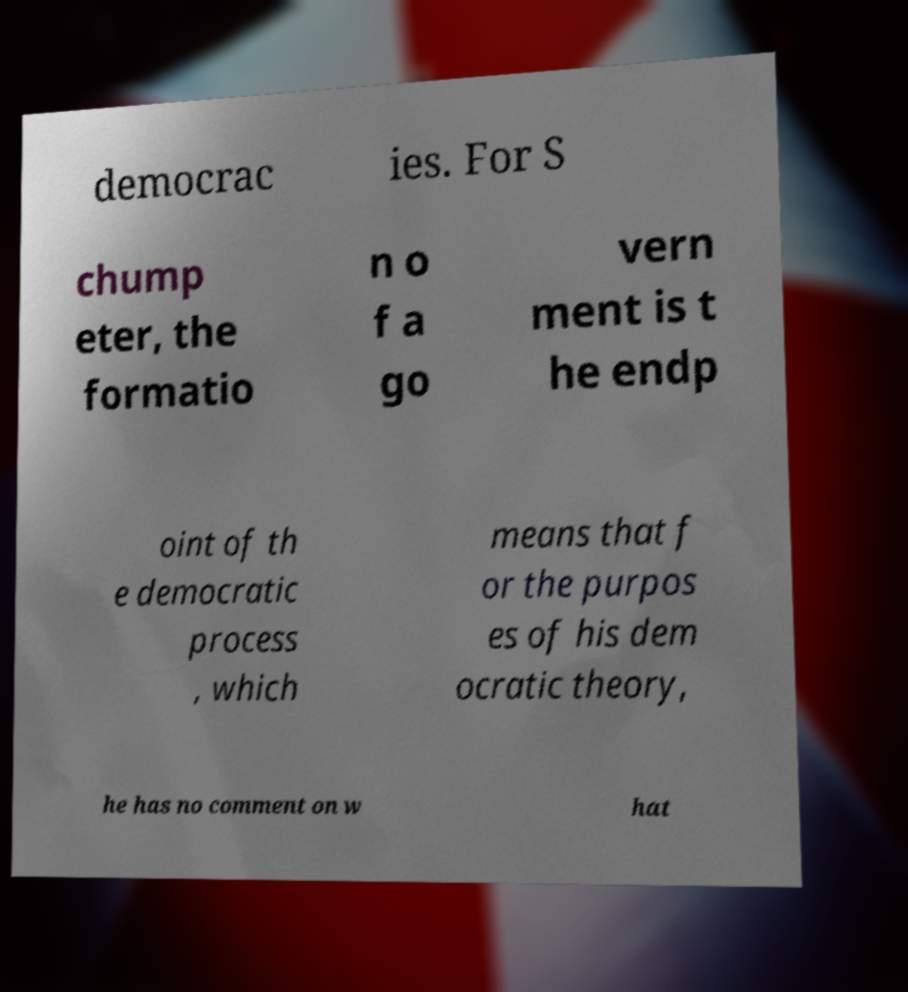I need the written content from this picture converted into text. Can you do that? democrac ies. For S chump eter, the formatio n o f a go vern ment is t he endp oint of th e democratic process , which means that f or the purpos es of his dem ocratic theory, he has no comment on w hat 